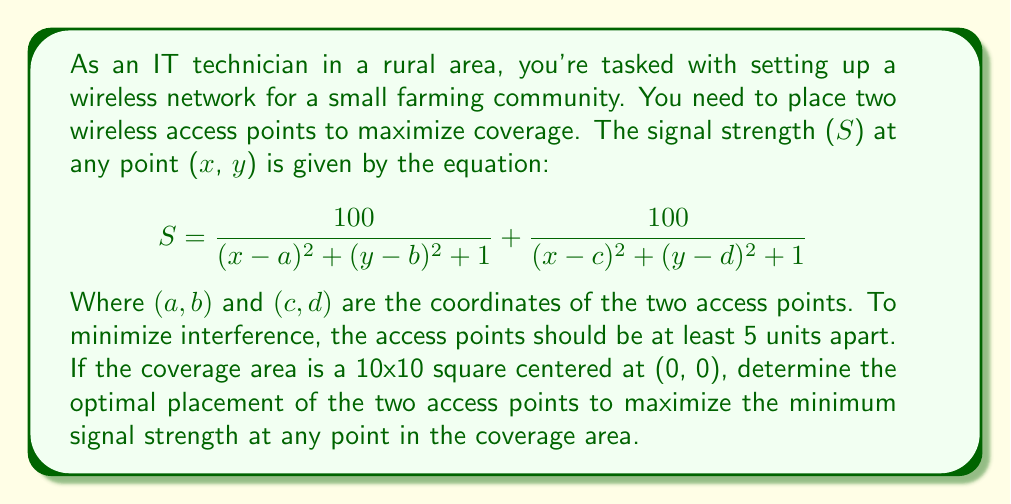Teach me how to tackle this problem. To solve this problem, we need to follow these steps:

1) First, we need to understand that the optimal placement will likely be symmetric due to the square coverage area. This suggests placing the access points equidistant from the center.

2) Given the interference constraint, the access points should be 5 units apart. The most symmetric way to do this is to place them on opposite corners of a 5x5 square centered at (0, 0).

3) The coordinates of these points would be (2.5, 2.5) and (-2.5, -2.5).

4) To verify this is optimal, we need to check the signal strength at the points furthest from both access points. These would be the other two corners of the 10x10 square: (5, -5) and (-5, 5).

5) Let's calculate the signal strength at (5, -5):

   $$S = \frac{100}{(5-2.5)^2 + (-5-2.5)^2 + 1} + \frac{100}{(5-(-2.5))^2 + (-5-(-2.5))^2 + 1}$$
   $$S = \frac{100}{2.5^2 + (-7.5)^2 + 1} + \frac{100}{7.5^2 + (-2.5)^2 + 1}$$
   $$S = \frac{100}{62.5 + 1} + \frac{100}{62.5 + 1} = \frac{200}{63.5} \approx 3.15$$

6) Due to symmetry, the signal strength at (-5, 5) would be the same.

7) We can verify that this is indeed the minimum signal strength by checking a few other points, but mathematically, these corners should have the lowest strength.

Therefore, the optimal placement for the two access points is at (2.5, 2.5) and (-2.5, -2.5), which results in a minimum signal strength of approximately 3.15 at any point in the coverage area.
Answer: The optimal placement for the two access points is at coordinates (2.5, 2.5) and (-2.5, -2.5), resulting in a minimum signal strength of approximately 3.15 throughout the coverage area. 